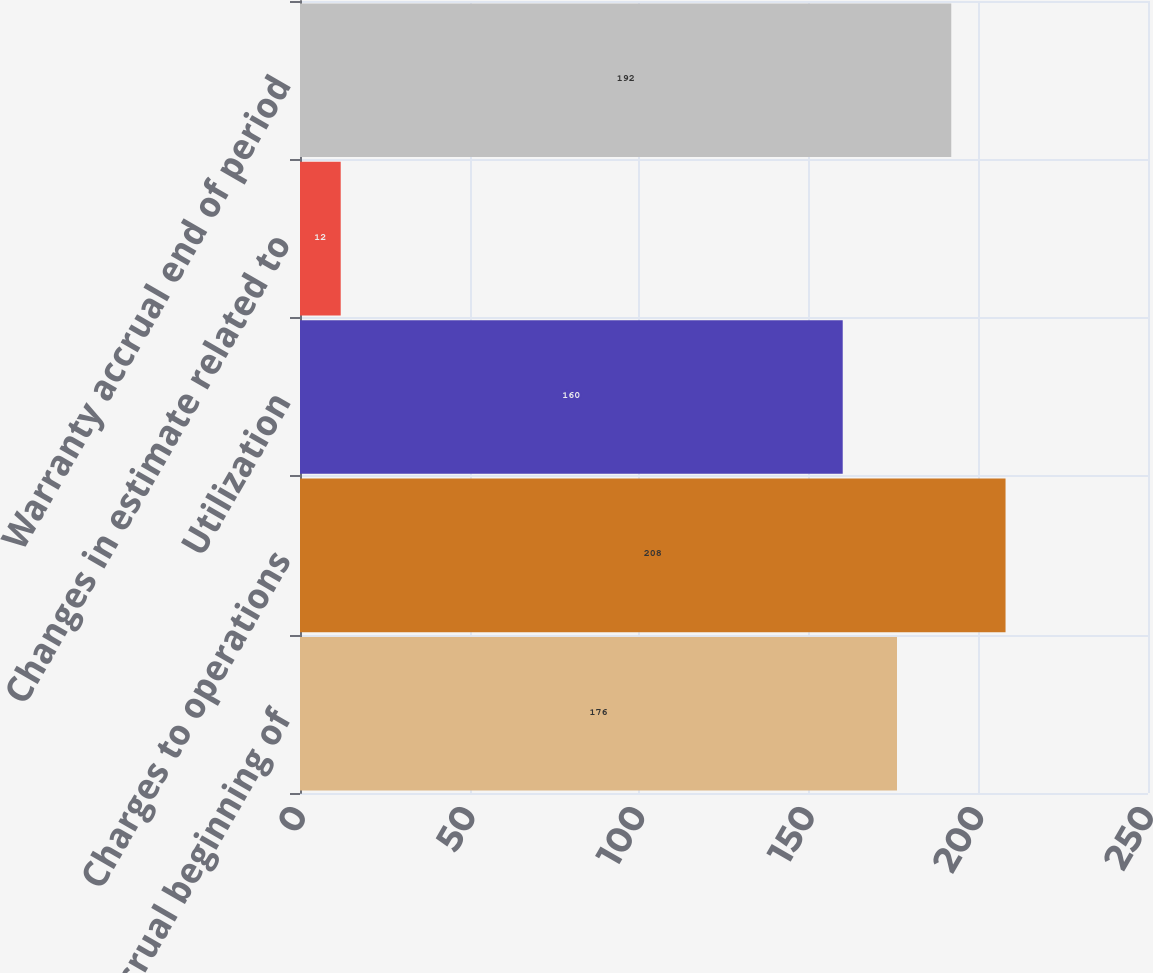<chart> <loc_0><loc_0><loc_500><loc_500><bar_chart><fcel>Warranty accrual beginning of<fcel>Charges to operations<fcel>Utilization<fcel>Changes in estimate related to<fcel>Warranty accrual end of period<nl><fcel>176<fcel>208<fcel>160<fcel>12<fcel>192<nl></chart> 